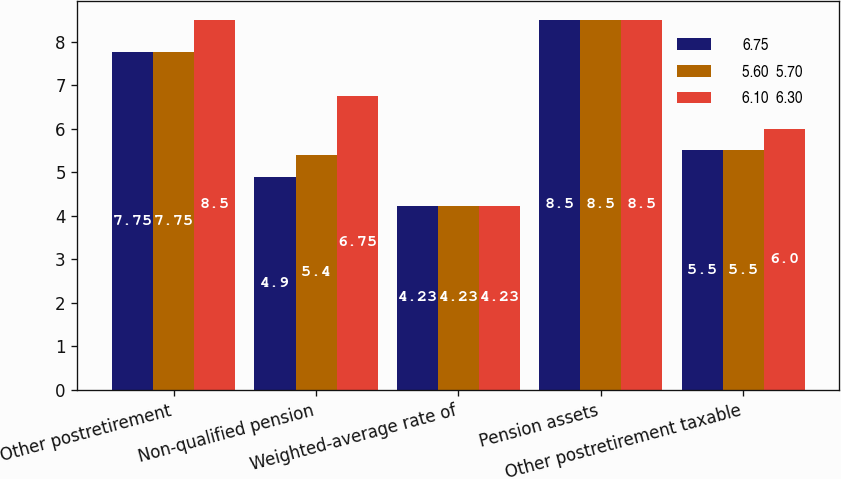Convert chart to OTSL. <chart><loc_0><loc_0><loc_500><loc_500><stacked_bar_chart><ecel><fcel>Other postretirement<fcel>Non-qualified pension<fcel>Weighted-average rate of<fcel>Pension assets<fcel>Other postretirement taxable<nl><fcel>6.75<fcel>7.75<fcel>4.9<fcel>4.23<fcel>8.5<fcel>5.5<nl><fcel>5.60  5.70<fcel>7.75<fcel>5.4<fcel>4.23<fcel>8.5<fcel>5.5<nl><fcel>6.10  6.30<fcel>8.5<fcel>6.75<fcel>4.23<fcel>8.5<fcel>6<nl></chart> 